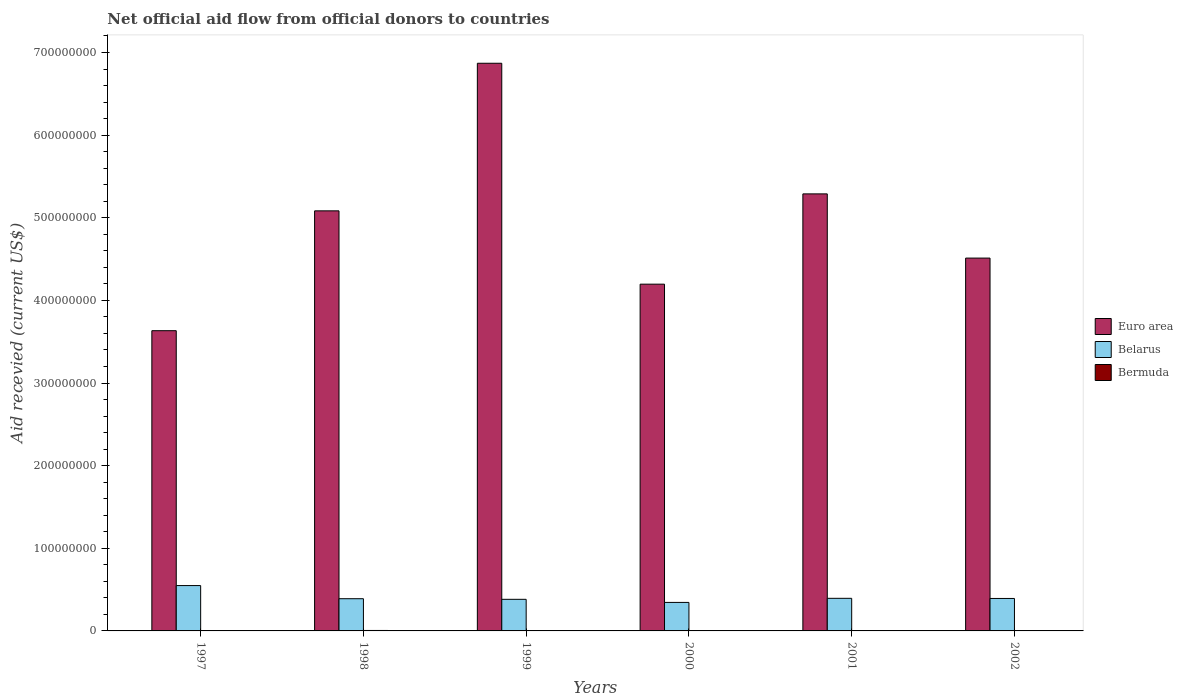How many different coloured bars are there?
Offer a very short reply. 3. How many bars are there on the 1st tick from the right?
Offer a very short reply. 3. What is the label of the 5th group of bars from the left?
Offer a terse response. 2001. In how many cases, is the number of bars for a given year not equal to the number of legend labels?
Ensure brevity in your answer.  1. What is the total aid received in Bermuda in 2002?
Provide a short and direct response. 2.00e+04. Across all years, what is the maximum total aid received in Bermuda?
Ensure brevity in your answer.  5.50e+05. Across all years, what is the minimum total aid received in Bermuda?
Your response must be concise. 0. What is the total total aid received in Bermuda in the graph?
Offer a very short reply. 7.30e+05. What is the difference between the total aid received in Belarus in 1997 and that in 1998?
Offer a terse response. 1.59e+07. What is the difference between the total aid received in Bermuda in 2001 and the total aid received in Euro area in 2002?
Offer a very short reply. -4.51e+08. What is the average total aid received in Bermuda per year?
Your answer should be compact. 1.22e+05. In the year 2002, what is the difference between the total aid received in Euro area and total aid received in Bermuda?
Make the answer very short. 4.51e+08. What is the ratio of the total aid received in Bermuda in 1999 to that in 2001?
Make the answer very short. 4. Is the total aid received in Bermuda in 1999 less than that in 2001?
Provide a succinct answer. No. What is the difference between the highest and the second highest total aid received in Euro area?
Provide a short and direct response. 1.58e+08. What is the difference between the highest and the lowest total aid received in Euro area?
Make the answer very short. 3.24e+08. Is the sum of the total aid received in Euro area in 2001 and 2002 greater than the maximum total aid received in Belarus across all years?
Provide a short and direct response. Yes. Is it the case that in every year, the sum of the total aid received in Belarus and total aid received in Bermuda is greater than the total aid received in Euro area?
Provide a succinct answer. No. How many bars are there?
Ensure brevity in your answer.  17. How many years are there in the graph?
Provide a succinct answer. 6. What is the difference between two consecutive major ticks on the Y-axis?
Offer a terse response. 1.00e+08. Are the values on the major ticks of Y-axis written in scientific E-notation?
Offer a terse response. No. Does the graph contain any zero values?
Your answer should be very brief. Yes. Where does the legend appear in the graph?
Give a very brief answer. Center right. How many legend labels are there?
Ensure brevity in your answer.  3. What is the title of the graph?
Provide a short and direct response. Net official aid flow from official donors to countries. Does "Greenland" appear as one of the legend labels in the graph?
Your answer should be compact. No. What is the label or title of the Y-axis?
Your answer should be compact. Aid recevied (current US$). What is the Aid recevied (current US$) of Euro area in 1997?
Your answer should be very brief. 3.63e+08. What is the Aid recevied (current US$) in Belarus in 1997?
Make the answer very short. 5.49e+07. What is the Aid recevied (current US$) in Euro area in 1998?
Make the answer very short. 5.08e+08. What is the Aid recevied (current US$) of Belarus in 1998?
Give a very brief answer. 3.90e+07. What is the Aid recevied (current US$) of Euro area in 1999?
Provide a short and direct response. 6.87e+08. What is the Aid recevied (current US$) of Belarus in 1999?
Offer a terse response. 3.82e+07. What is the Aid recevied (current US$) of Euro area in 2000?
Provide a succinct answer. 4.20e+08. What is the Aid recevied (current US$) in Belarus in 2000?
Make the answer very short. 3.45e+07. What is the Aid recevied (current US$) of Euro area in 2001?
Your response must be concise. 5.29e+08. What is the Aid recevied (current US$) in Belarus in 2001?
Provide a short and direct response. 3.94e+07. What is the Aid recevied (current US$) in Euro area in 2002?
Make the answer very short. 4.51e+08. What is the Aid recevied (current US$) in Belarus in 2002?
Provide a short and direct response. 3.93e+07. What is the Aid recevied (current US$) in Bermuda in 2002?
Your answer should be compact. 2.00e+04. Across all years, what is the maximum Aid recevied (current US$) of Euro area?
Your answer should be very brief. 6.87e+08. Across all years, what is the maximum Aid recevied (current US$) of Belarus?
Keep it short and to the point. 5.49e+07. Across all years, what is the maximum Aid recevied (current US$) in Bermuda?
Ensure brevity in your answer.  5.50e+05. Across all years, what is the minimum Aid recevied (current US$) of Euro area?
Make the answer very short. 3.63e+08. Across all years, what is the minimum Aid recevied (current US$) in Belarus?
Ensure brevity in your answer.  3.45e+07. What is the total Aid recevied (current US$) in Euro area in the graph?
Your answer should be compact. 2.96e+09. What is the total Aid recevied (current US$) in Belarus in the graph?
Offer a terse response. 2.45e+08. What is the total Aid recevied (current US$) of Bermuda in the graph?
Offer a terse response. 7.30e+05. What is the difference between the Aid recevied (current US$) of Euro area in 1997 and that in 1998?
Give a very brief answer. -1.45e+08. What is the difference between the Aid recevied (current US$) of Belarus in 1997 and that in 1998?
Ensure brevity in your answer.  1.59e+07. What is the difference between the Aid recevied (current US$) in Euro area in 1997 and that in 1999?
Ensure brevity in your answer.  -3.24e+08. What is the difference between the Aid recevied (current US$) of Belarus in 1997 and that in 1999?
Give a very brief answer. 1.66e+07. What is the difference between the Aid recevied (current US$) of Euro area in 1997 and that in 2000?
Keep it short and to the point. -5.63e+07. What is the difference between the Aid recevied (current US$) in Belarus in 1997 and that in 2000?
Provide a short and direct response. 2.04e+07. What is the difference between the Aid recevied (current US$) in Euro area in 1997 and that in 2001?
Offer a very short reply. -1.66e+08. What is the difference between the Aid recevied (current US$) of Belarus in 1997 and that in 2001?
Your answer should be compact. 1.54e+07. What is the difference between the Aid recevied (current US$) in Euro area in 1997 and that in 2002?
Offer a terse response. -8.79e+07. What is the difference between the Aid recevied (current US$) of Belarus in 1997 and that in 2002?
Keep it short and to the point. 1.56e+07. What is the difference between the Aid recevied (current US$) of Euro area in 1998 and that in 1999?
Offer a terse response. -1.79e+08. What is the difference between the Aid recevied (current US$) of Belarus in 1998 and that in 1999?
Provide a short and direct response. 7.30e+05. What is the difference between the Aid recevied (current US$) in Bermuda in 1998 and that in 1999?
Offer a very short reply. 4.70e+05. What is the difference between the Aid recevied (current US$) of Euro area in 1998 and that in 2000?
Ensure brevity in your answer.  8.87e+07. What is the difference between the Aid recevied (current US$) of Belarus in 1998 and that in 2000?
Offer a very short reply. 4.49e+06. What is the difference between the Aid recevied (current US$) of Bermuda in 1998 and that in 2000?
Your response must be concise. 4.90e+05. What is the difference between the Aid recevied (current US$) in Euro area in 1998 and that in 2001?
Your answer should be compact. -2.05e+07. What is the difference between the Aid recevied (current US$) of Belarus in 1998 and that in 2001?
Offer a terse response. -4.70e+05. What is the difference between the Aid recevied (current US$) of Bermuda in 1998 and that in 2001?
Offer a terse response. 5.30e+05. What is the difference between the Aid recevied (current US$) in Euro area in 1998 and that in 2002?
Your answer should be very brief. 5.72e+07. What is the difference between the Aid recevied (current US$) in Bermuda in 1998 and that in 2002?
Your answer should be compact. 5.30e+05. What is the difference between the Aid recevied (current US$) in Euro area in 1999 and that in 2000?
Give a very brief answer. 2.67e+08. What is the difference between the Aid recevied (current US$) in Belarus in 1999 and that in 2000?
Provide a succinct answer. 3.76e+06. What is the difference between the Aid recevied (current US$) in Bermuda in 1999 and that in 2000?
Ensure brevity in your answer.  2.00e+04. What is the difference between the Aid recevied (current US$) in Euro area in 1999 and that in 2001?
Offer a very short reply. 1.58e+08. What is the difference between the Aid recevied (current US$) in Belarus in 1999 and that in 2001?
Offer a terse response. -1.20e+06. What is the difference between the Aid recevied (current US$) of Euro area in 1999 and that in 2002?
Your answer should be compact. 2.36e+08. What is the difference between the Aid recevied (current US$) in Belarus in 1999 and that in 2002?
Ensure brevity in your answer.  -1.03e+06. What is the difference between the Aid recevied (current US$) of Euro area in 2000 and that in 2001?
Keep it short and to the point. -1.09e+08. What is the difference between the Aid recevied (current US$) of Belarus in 2000 and that in 2001?
Give a very brief answer. -4.96e+06. What is the difference between the Aid recevied (current US$) in Euro area in 2000 and that in 2002?
Ensure brevity in your answer.  -3.16e+07. What is the difference between the Aid recevied (current US$) of Belarus in 2000 and that in 2002?
Offer a very short reply. -4.79e+06. What is the difference between the Aid recevied (current US$) in Euro area in 2001 and that in 2002?
Ensure brevity in your answer.  7.77e+07. What is the difference between the Aid recevied (current US$) in Euro area in 1997 and the Aid recevied (current US$) in Belarus in 1998?
Offer a very short reply. 3.24e+08. What is the difference between the Aid recevied (current US$) in Euro area in 1997 and the Aid recevied (current US$) in Bermuda in 1998?
Keep it short and to the point. 3.63e+08. What is the difference between the Aid recevied (current US$) in Belarus in 1997 and the Aid recevied (current US$) in Bermuda in 1998?
Provide a short and direct response. 5.43e+07. What is the difference between the Aid recevied (current US$) of Euro area in 1997 and the Aid recevied (current US$) of Belarus in 1999?
Your answer should be very brief. 3.25e+08. What is the difference between the Aid recevied (current US$) in Euro area in 1997 and the Aid recevied (current US$) in Bermuda in 1999?
Provide a succinct answer. 3.63e+08. What is the difference between the Aid recevied (current US$) of Belarus in 1997 and the Aid recevied (current US$) of Bermuda in 1999?
Your answer should be very brief. 5.48e+07. What is the difference between the Aid recevied (current US$) of Euro area in 1997 and the Aid recevied (current US$) of Belarus in 2000?
Offer a terse response. 3.29e+08. What is the difference between the Aid recevied (current US$) in Euro area in 1997 and the Aid recevied (current US$) in Bermuda in 2000?
Provide a succinct answer. 3.63e+08. What is the difference between the Aid recevied (current US$) in Belarus in 1997 and the Aid recevied (current US$) in Bermuda in 2000?
Keep it short and to the point. 5.48e+07. What is the difference between the Aid recevied (current US$) in Euro area in 1997 and the Aid recevied (current US$) in Belarus in 2001?
Give a very brief answer. 3.24e+08. What is the difference between the Aid recevied (current US$) in Euro area in 1997 and the Aid recevied (current US$) in Bermuda in 2001?
Give a very brief answer. 3.63e+08. What is the difference between the Aid recevied (current US$) in Belarus in 1997 and the Aid recevied (current US$) in Bermuda in 2001?
Provide a succinct answer. 5.49e+07. What is the difference between the Aid recevied (current US$) of Euro area in 1997 and the Aid recevied (current US$) of Belarus in 2002?
Give a very brief answer. 3.24e+08. What is the difference between the Aid recevied (current US$) of Euro area in 1997 and the Aid recevied (current US$) of Bermuda in 2002?
Offer a very short reply. 3.63e+08. What is the difference between the Aid recevied (current US$) in Belarus in 1997 and the Aid recevied (current US$) in Bermuda in 2002?
Offer a terse response. 5.49e+07. What is the difference between the Aid recevied (current US$) in Euro area in 1998 and the Aid recevied (current US$) in Belarus in 1999?
Make the answer very short. 4.70e+08. What is the difference between the Aid recevied (current US$) in Euro area in 1998 and the Aid recevied (current US$) in Bermuda in 1999?
Give a very brief answer. 5.08e+08. What is the difference between the Aid recevied (current US$) in Belarus in 1998 and the Aid recevied (current US$) in Bermuda in 1999?
Your response must be concise. 3.89e+07. What is the difference between the Aid recevied (current US$) of Euro area in 1998 and the Aid recevied (current US$) of Belarus in 2000?
Your answer should be compact. 4.74e+08. What is the difference between the Aid recevied (current US$) in Euro area in 1998 and the Aid recevied (current US$) in Bermuda in 2000?
Ensure brevity in your answer.  5.08e+08. What is the difference between the Aid recevied (current US$) in Belarus in 1998 and the Aid recevied (current US$) in Bermuda in 2000?
Make the answer very short. 3.89e+07. What is the difference between the Aid recevied (current US$) of Euro area in 1998 and the Aid recevied (current US$) of Belarus in 2001?
Offer a very short reply. 4.69e+08. What is the difference between the Aid recevied (current US$) in Euro area in 1998 and the Aid recevied (current US$) in Bermuda in 2001?
Your answer should be very brief. 5.08e+08. What is the difference between the Aid recevied (current US$) of Belarus in 1998 and the Aid recevied (current US$) of Bermuda in 2001?
Your response must be concise. 3.90e+07. What is the difference between the Aid recevied (current US$) of Euro area in 1998 and the Aid recevied (current US$) of Belarus in 2002?
Offer a terse response. 4.69e+08. What is the difference between the Aid recevied (current US$) in Euro area in 1998 and the Aid recevied (current US$) in Bermuda in 2002?
Offer a very short reply. 5.08e+08. What is the difference between the Aid recevied (current US$) in Belarus in 1998 and the Aid recevied (current US$) in Bermuda in 2002?
Ensure brevity in your answer.  3.90e+07. What is the difference between the Aid recevied (current US$) in Euro area in 1999 and the Aid recevied (current US$) in Belarus in 2000?
Provide a succinct answer. 6.52e+08. What is the difference between the Aid recevied (current US$) in Euro area in 1999 and the Aid recevied (current US$) in Bermuda in 2000?
Give a very brief answer. 6.87e+08. What is the difference between the Aid recevied (current US$) in Belarus in 1999 and the Aid recevied (current US$) in Bermuda in 2000?
Ensure brevity in your answer.  3.82e+07. What is the difference between the Aid recevied (current US$) in Euro area in 1999 and the Aid recevied (current US$) in Belarus in 2001?
Provide a succinct answer. 6.48e+08. What is the difference between the Aid recevied (current US$) in Euro area in 1999 and the Aid recevied (current US$) in Bermuda in 2001?
Your response must be concise. 6.87e+08. What is the difference between the Aid recevied (current US$) in Belarus in 1999 and the Aid recevied (current US$) in Bermuda in 2001?
Your answer should be very brief. 3.82e+07. What is the difference between the Aid recevied (current US$) in Euro area in 1999 and the Aid recevied (current US$) in Belarus in 2002?
Give a very brief answer. 6.48e+08. What is the difference between the Aid recevied (current US$) of Euro area in 1999 and the Aid recevied (current US$) of Bermuda in 2002?
Your answer should be compact. 6.87e+08. What is the difference between the Aid recevied (current US$) in Belarus in 1999 and the Aid recevied (current US$) in Bermuda in 2002?
Make the answer very short. 3.82e+07. What is the difference between the Aid recevied (current US$) in Euro area in 2000 and the Aid recevied (current US$) in Belarus in 2001?
Provide a succinct answer. 3.80e+08. What is the difference between the Aid recevied (current US$) of Euro area in 2000 and the Aid recevied (current US$) of Bermuda in 2001?
Ensure brevity in your answer.  4.20e+08. What is the difference between the Aid recevied (current US$) of Belarus in 2000 and the Aid recevied (current US$) of Bermuda in 2001?
Offer a terse response. 3.45e+07. What is the difference between the Aid recevied (current US$) in Euro area in 2000 and the Aid recevied (current US$) in Belarus in 2002?
Offer a very short reply. 3.80e+08. What is the difference between the Aid recevied (current US$) in Euro area in 2000 and the Aid recevied (current US$) in Bermuda in 2002?
Offer a terse response. 4.20e+08. What is the difference between the Aid recevied (current US$) in Belarus in 2000 and the Aid recevied (current US$) in Bermuda in 2002?
Ensure brevity in your answer.  3.45e+07. What is the difference between the Aid recevied (current US$) in Euro area in 2001 and the Aid recevied (current US$) in Belarus in 2002?
Offer a very short reply. 4.90e+08. What is the difference between the Aid recevied (current US$) of Euro area in 2001 and the Aid recevied (current US$) of Bermuda in 2002?
Your answer should be compact. 5.29e+08. What is the difference between the Aid recevied (current US$) in Belarus in 2001 and the Aid recevied (current US$) in Bermuda in 2002?
Ensure brevity in your answer.  3.94e+07. What is the average Aid recevied (current US$) of Euro area per year?
Keep it short and to the point. 4.93e+08. What is the average Aid recevied (current US$) in Belarus per year?
Offer a very short reply. 4.09e+07. What is the average Aid recevied (current US$) in Bermuda per year?
Provide a short and direct response. 1.22e+05. In the year 1997, what is the difference between the Aid recevied (current US$) in Euro area and Aid recevied (current US$) in Belarus?
Make the answer very short. 3.08e+08. In the year 1998, what is the difference between the Aid recevied (current US$) of Euro area and Aid recevied (current US$) of Belarus?
Provide a succinct answer. 4.69e+08. In the year 1998, what is the difference between the Aid recevied (current US$) in Euro area and Aid recevied (current US$) in Bermuda?
Provide a succinct answer. 5.08e+08. In the year 1998, what is the difference between the Aid recevied (current US$) in Belarus and Aid recevied (current US$) in Bermuda?
Your answer should be compact. 3.84e+07. In the year 1999, what is the difference between the Aid recevied (current US$) of Euro area and Aid recevied (current US$) of Belarus?
Your answer should be compact. 6.49e+08. In the year 1999, what is the difference between the Aid recevied (current US$) of Euro area and Aid recevied (current US$) of Bermuda?
Your answer should be very brief. 6.87e+08. In the year 1999, what is the difference between the Aid recevied (current US$) in Belarus and Aid recevied (current US$) in Bermuda?
Offer a terse response. 3.82e+07. In the year 2000, what is the difference between the Aid recevied (current US$) in Euro area and Aid recevied (current US$) in Belarus?
Your response must be concise. 3.85e+08. In the year 2000, what is the difference between the Aid recevied (current US$) of Euro area and Aid recevied (current US$) of Bermuda?
Your response must be concise. 4.20e+08. In the year 2000, what is the difference between the Aid recevied (current US$) of Belarus and Aid recevied (current US$) of Bermuda?
Your answer should be compact. 3.44e+07. In the year 2001, what is the difference between the Aid recevied (current US$) in Euro area and Aid recevied (current US$) in Belarus?
Your response must be concise. 4.89e+08. In the year 2001, what is the difference between the Aid recevied (current US$) in Euro area and Aid recevied (current US$) in Bermuda?
Provide a succinct answer. 5.29e+08. In the year 2001, what is the difference between the Aid recevied (current US$) in Belarus and Aid recevied (current US$) in Bermuda?
Your answer should be very brief. 3.94e+07. In the year 2002, what is the difference between the Aid recevied (current US$) in Euro area and Aid recevied (current US$) in Belarus?
Provide a short and direct response. 4.12e+08. In the year 2002, what is the difference between the Aid recevied (current US$) of Euro area and Aid recevied (current US$) of Bermuda?
Offer a very short reply. 4.51e+08. In the year 2002, what is the difference between the Aid recevied (current US$) of Belarus and Aid recevied (current US$) of Bermuda?
Your response must be concise. 3.93e+07. What is the ratio of the Aid recevied (current US$) in Euro area in 1997 to that in 1998?
Provide a succinct answer. 0.71. What is the ratio of the Aid recevied (current US$) of Belarus in 1997 to that in 1998?
Give a very brief answer. 1.41. What is the ratio of the Aid recevied (current US$) in Euro area in 1997 to that in 1999?
Ensure brevity in your answer.  0.53. What is the ratio of the Aid recevied (current US$) in Belarus in 1997 to that in 1999?
Ensure brevity in your answer.  1.43. What is the ratio of the Aid recevied (current US$) in Euro area in 1997 to that in 2000?
Offer a very short reply. 0.87. What is the ratio of the Aid recevied (current US$) of Belarus in 1997 to that in 2000?
Provide a short and direct response. 1.59. What is the ratio of the Aid recevied (current US$) of Euro area in 1997 to that in 2001?
Provide a short and direct response. 0.69. What is the ratio of the Aid recevied (current US$) in Belarus in 1997 to that in 2001?
Give a very brief answer. 1.39. What is the ratio of the Aid recevied (current US$) in Euro area in 1997 to that in 2002?
Make the answer very short. 0.81. What is the ratio of the Aid recevied (current US$) in Belarus in 1997 to that in 2002?
Keep it short and to the point. 1.4. What is the ratio of the Aid recevied (current US$) of Euro area in 1998 to that in 1999?
Keep it short and to the point. 0.74. What is the ratio of the Aid recevied (current US$) of Belarus in 1998 to that in 1999?
Your answer should be very brief. 1.02. What is the ratio of the Aid recevied (current US$) of Bermuda in 1998 to that in 1999?
Your answer should be compact. 6.88. What is the ratio of the Aid recevied (current US$) of Euro area in 1998 to that in 2000?
Make the answer very short. 1.21. What is the ratio of the Aid recevied (current US$) in Belarus in 1998 to that in 2000?
Ensure brevity in your answer.  1.13. What is the ratio of the Aid recevied (current US$) of Bermuda in 1998 to that in 2000?
Provide a succinct answer. 9.17. What is the ratio of the Aid recevied (current US$) of Euro area in 1998 to that in 2001?
Give a very brief answer. 0.96. What is the ratio of the Aid recevied (current US$) of Euro area in 1998 to that in 2002?
Your answer should be compact. 1.13. What is the ratio of the Aid recevied (current US$) of Bermuda in 1998 to that in 2002?
Make the answer very short. 27.5. What is the ratio of the Aid recevied (current US$) of Euro area in 1999 to that in 2000?
Your answer should be very brief. 1.64. What is the ratio of the Aid recevied (current US$) in Belarus in 1999 to that in 2000?
Make the answer very short. 1.11. What is the ratio of the Aid recevied (current US$) of Euro area in 1999 to that in 2001?
Ensure brevity in your answer.  1.3. What is the ratio of the Aid recevied (current US$) of Belarus in 1999 to that in 2001?
Your answer should be very brief. 0.97. What is the ratio of the Aid recevied (current US$) of Euro area in 1999 to that in 2002?
Offer a very short reply. 1.52. What is the ratio of the Aid recevied (current US$) in Belarus in 1999 to that in 2002?
Offer a terse response. 0.97. What is the ratio of the Aid recevied (current US$) in Bermuda in 1999 to that in 2002?
Your answer should be compact. 4. What is the ratio of the Aid recevied (current US$) in Euro area in 2000 to that in 2001?
Make the answer very short. 0.79. What is the ratio of the Aid recevied (current US$) of Belarus in 2000 to that in 2001?
Make the answer very short. 0.87. What is the ratio of the Aid recevied (current US$) of Euro area in 2000 to that in 2002?
Ensure brevity in your answer.  0.93. What is the ratio of the Aid recevied (current US$) in Belarus in 2000 to that in 2002?
Provide a short and direct response. 0.88. What is the ratio of the Aid recevied (current US$) in Bermuda in 2000 to that in 2002?
Give a very brief answer. 3. What is the ratio of the Aid recevied (current US$) of Euro area in 2001 to that in 2002?
Your answer should be very brief. 1.17. What is the ratio of the Aid recevied (current US$) in Belarus in 2001 to that in 2002?
Make the answer very short. 1. What is the ratio of the Aid recevied (current US$) in Bermuda in 2001 to that in 2002?
Your answer should be compact. 1. What is the difference between the highest and the second highest Aid recevied (current US$) in Euro area?
Provide a succinct answer. 1.58e+08. What is the difference between the highest and the second highest Aid recevied (current US$) in Belarus?
Give a very brief answer. 1.54e+07. What is the difference between the highest and the lowest Aid recevied (current US$) of Euro area?
Offer a very short reply. 3.24e+08. What is the difference between the highest and the lowest Aid recevied (current US$) in Belarus?
Your answer should be compact. 2.04e+07. What is the difference between the highest and the lowest Aid recevied (current US$) of Bermuda?
Your answer should be very brief. 5.50e+05. 